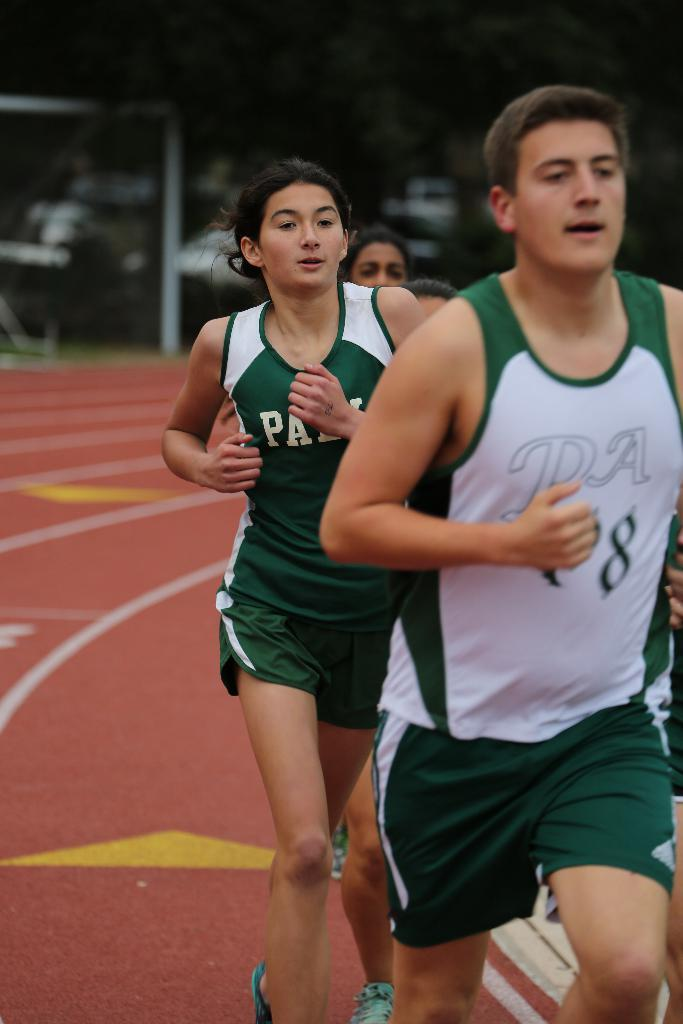<image>
Present a compact description of the photo's key features. A man and a girl are running on a track and their tank tops say PA. 